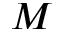<formula> <loc_0><loc_0><loc_500><loc_500>M</formula> 